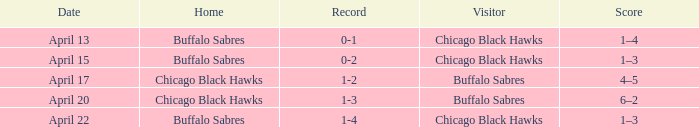Which Score has a Visitor of buffalo sabres and a Record of 1-3? 6–2. 